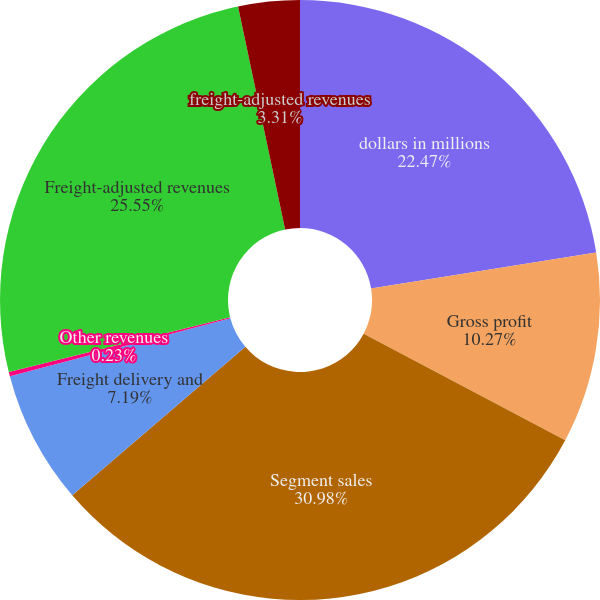<chart> <loc_0><loc_0><loc_500><loc_500><pie_chart><fcel>dollars in millions<fcel>Gross profit<fcel>Segment sales<fcel>Freight delivery and<fcel>Other revenues<fcel>Freight-adjusted revenues<fcel>freight-adjusted revenues<nl><fcel>22.47%<fcel>10.27%<fcel>30.98%<fcel>7.19%<fcel>0.23%<fcel>25.55%<fcel>3.31%<nl></chart> 